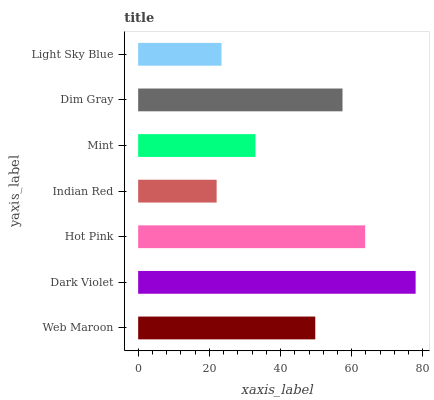Is Indian Red the minimum?
Answer yes or no. Yes. Is Dark Violet the maximum?
Answer yes or no. Yes. Is Hot Pink the minimum?
Answer yes or no. No. Is Hot Pink the maximum?
Answer yes or no. No. Is Dark Violet greater than Hot Pink?
Answer yes or no. Yes. Is Hot Pink less than Dark Violet?
Answer yes or no. Yes. Is Hot Pink greater than Dark Violet?
Answer yes or no. No. Is Dark Violet less than Hot Pink?
Answer yes or no. No. Is Web Maroon the high median?
Answer yes or no. Yes. Is Web Maroon the low median?
Answer yes or no. Yes. Is Light Sky Blue the high median?
Answer yes or no. No. Is Mint the low median?
Answer yes or no. No. 